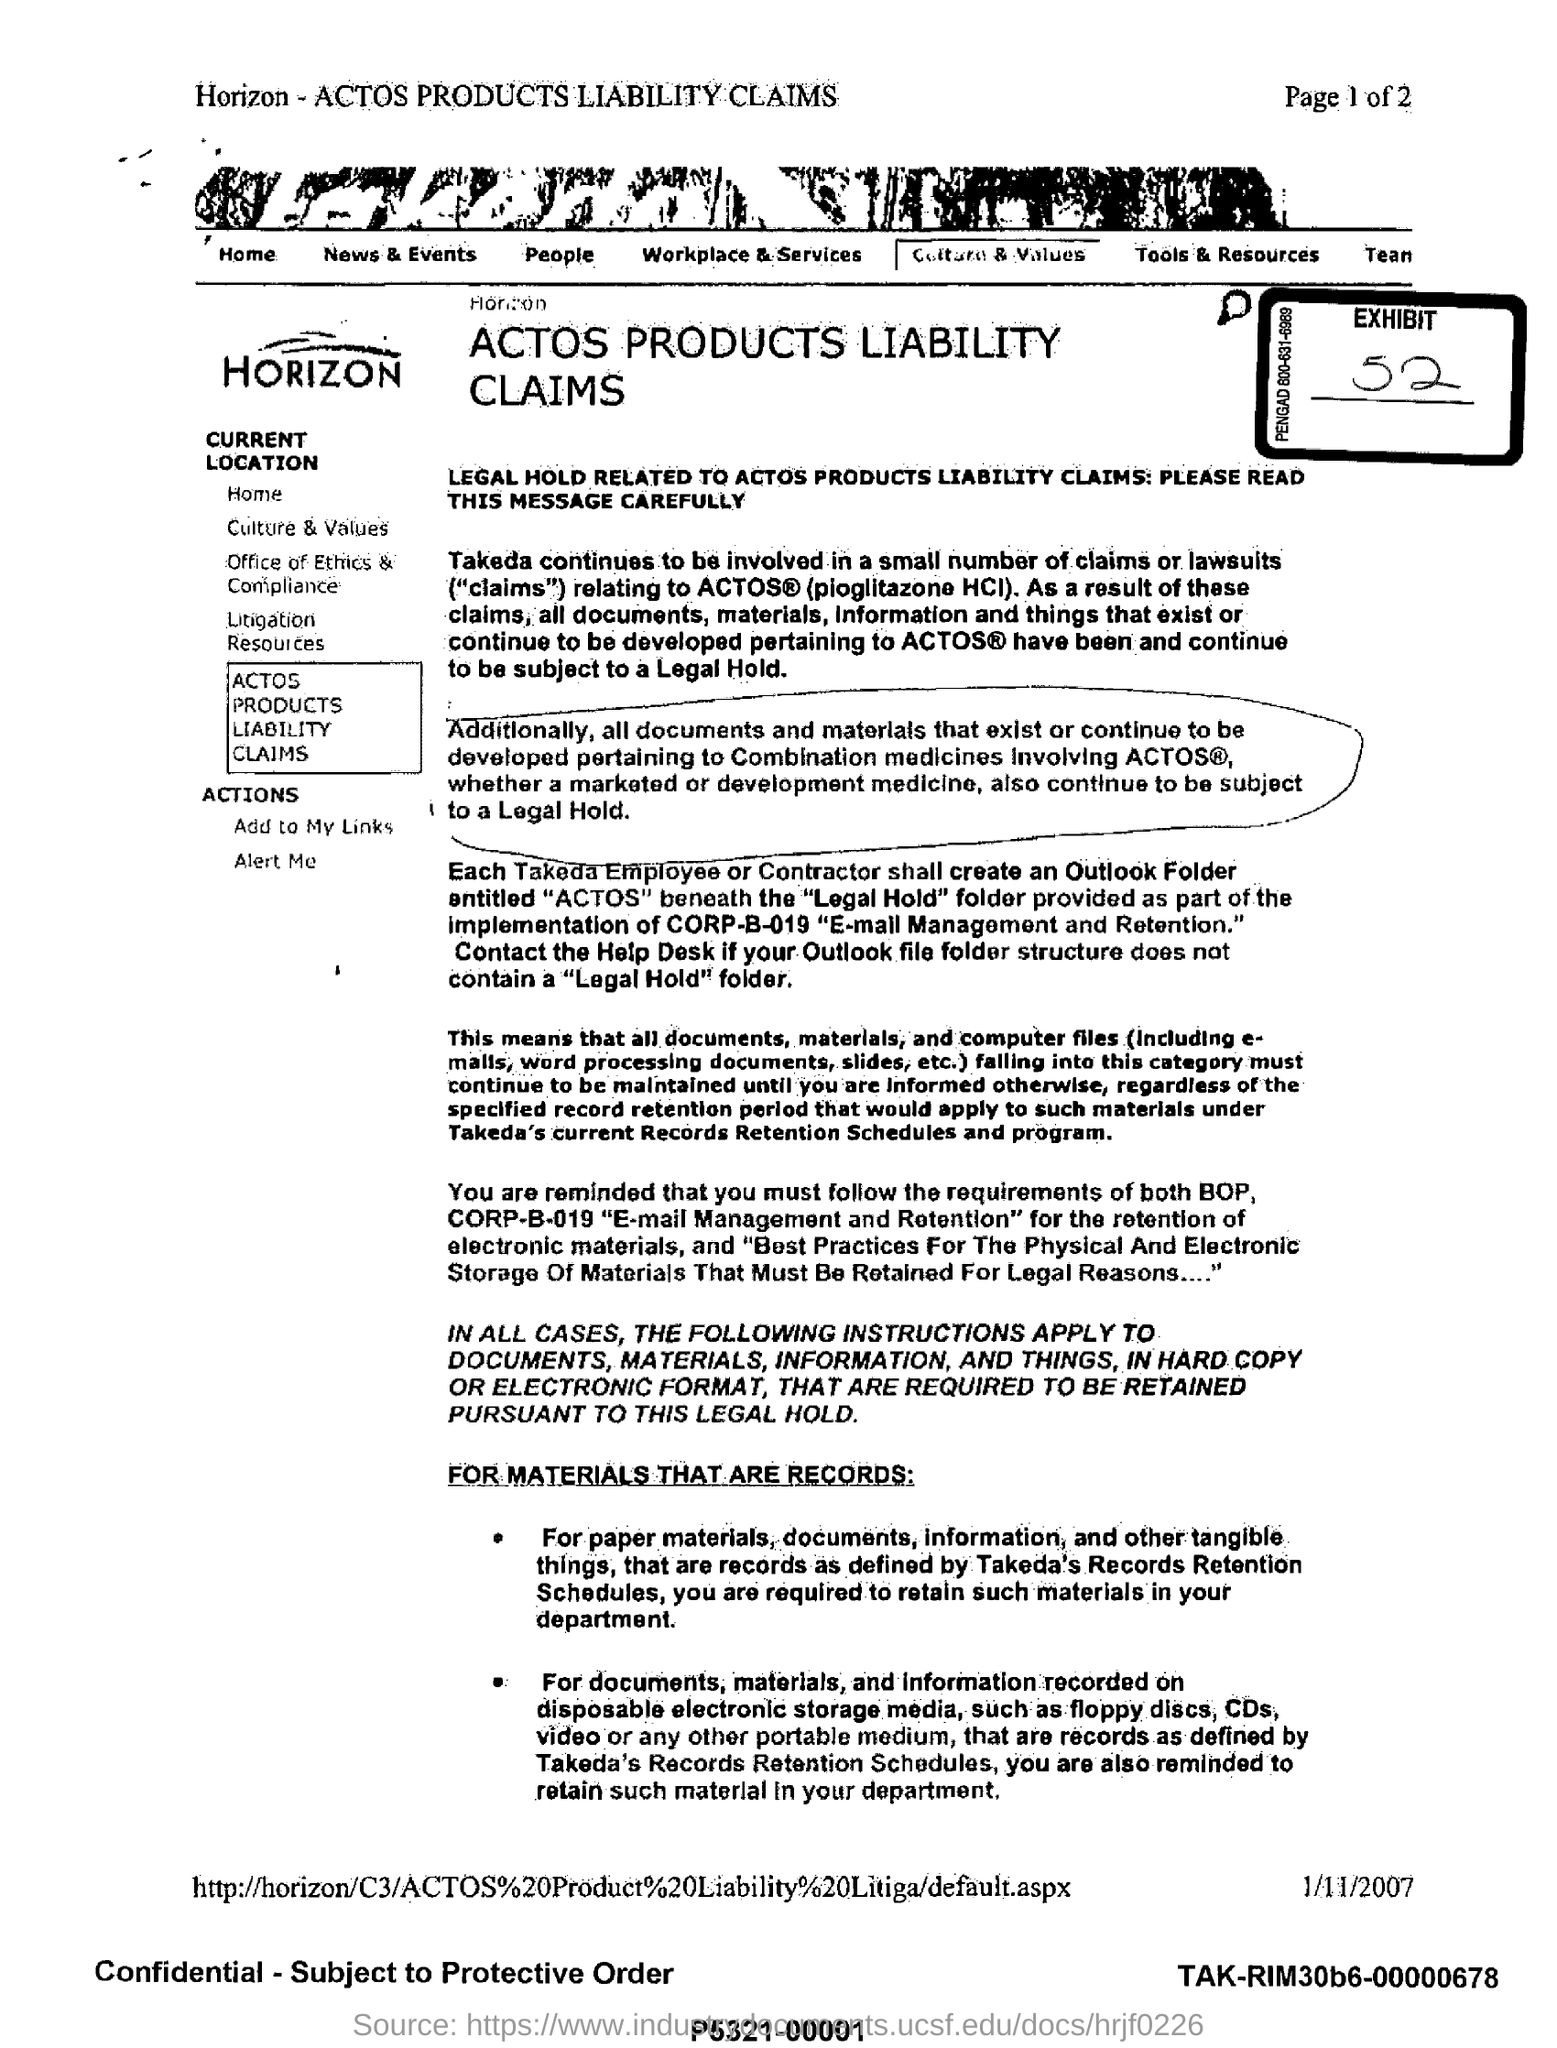Draw attention to some important aspects in this diagram. The exhibit number is 52. The document indicates that the date mentioned is 1/11/2007. The liability claims described here pertain to the product known as Actos. 